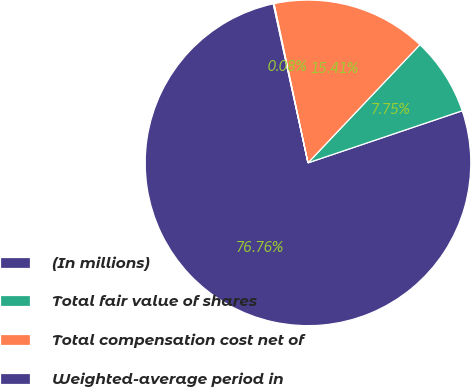Convert chart. <chart><loc_0><loc_0><loc_500><loc_500><pie_chart><fcel>(In millions)<fcel>Total fair value of shares<fcel>Total compensation cost net of<fcel>Weighted-average period in<nl><fcel>76.76%<fcel>7.75%<fcel>15.41%<fcel>0.08%<nl></chart> 